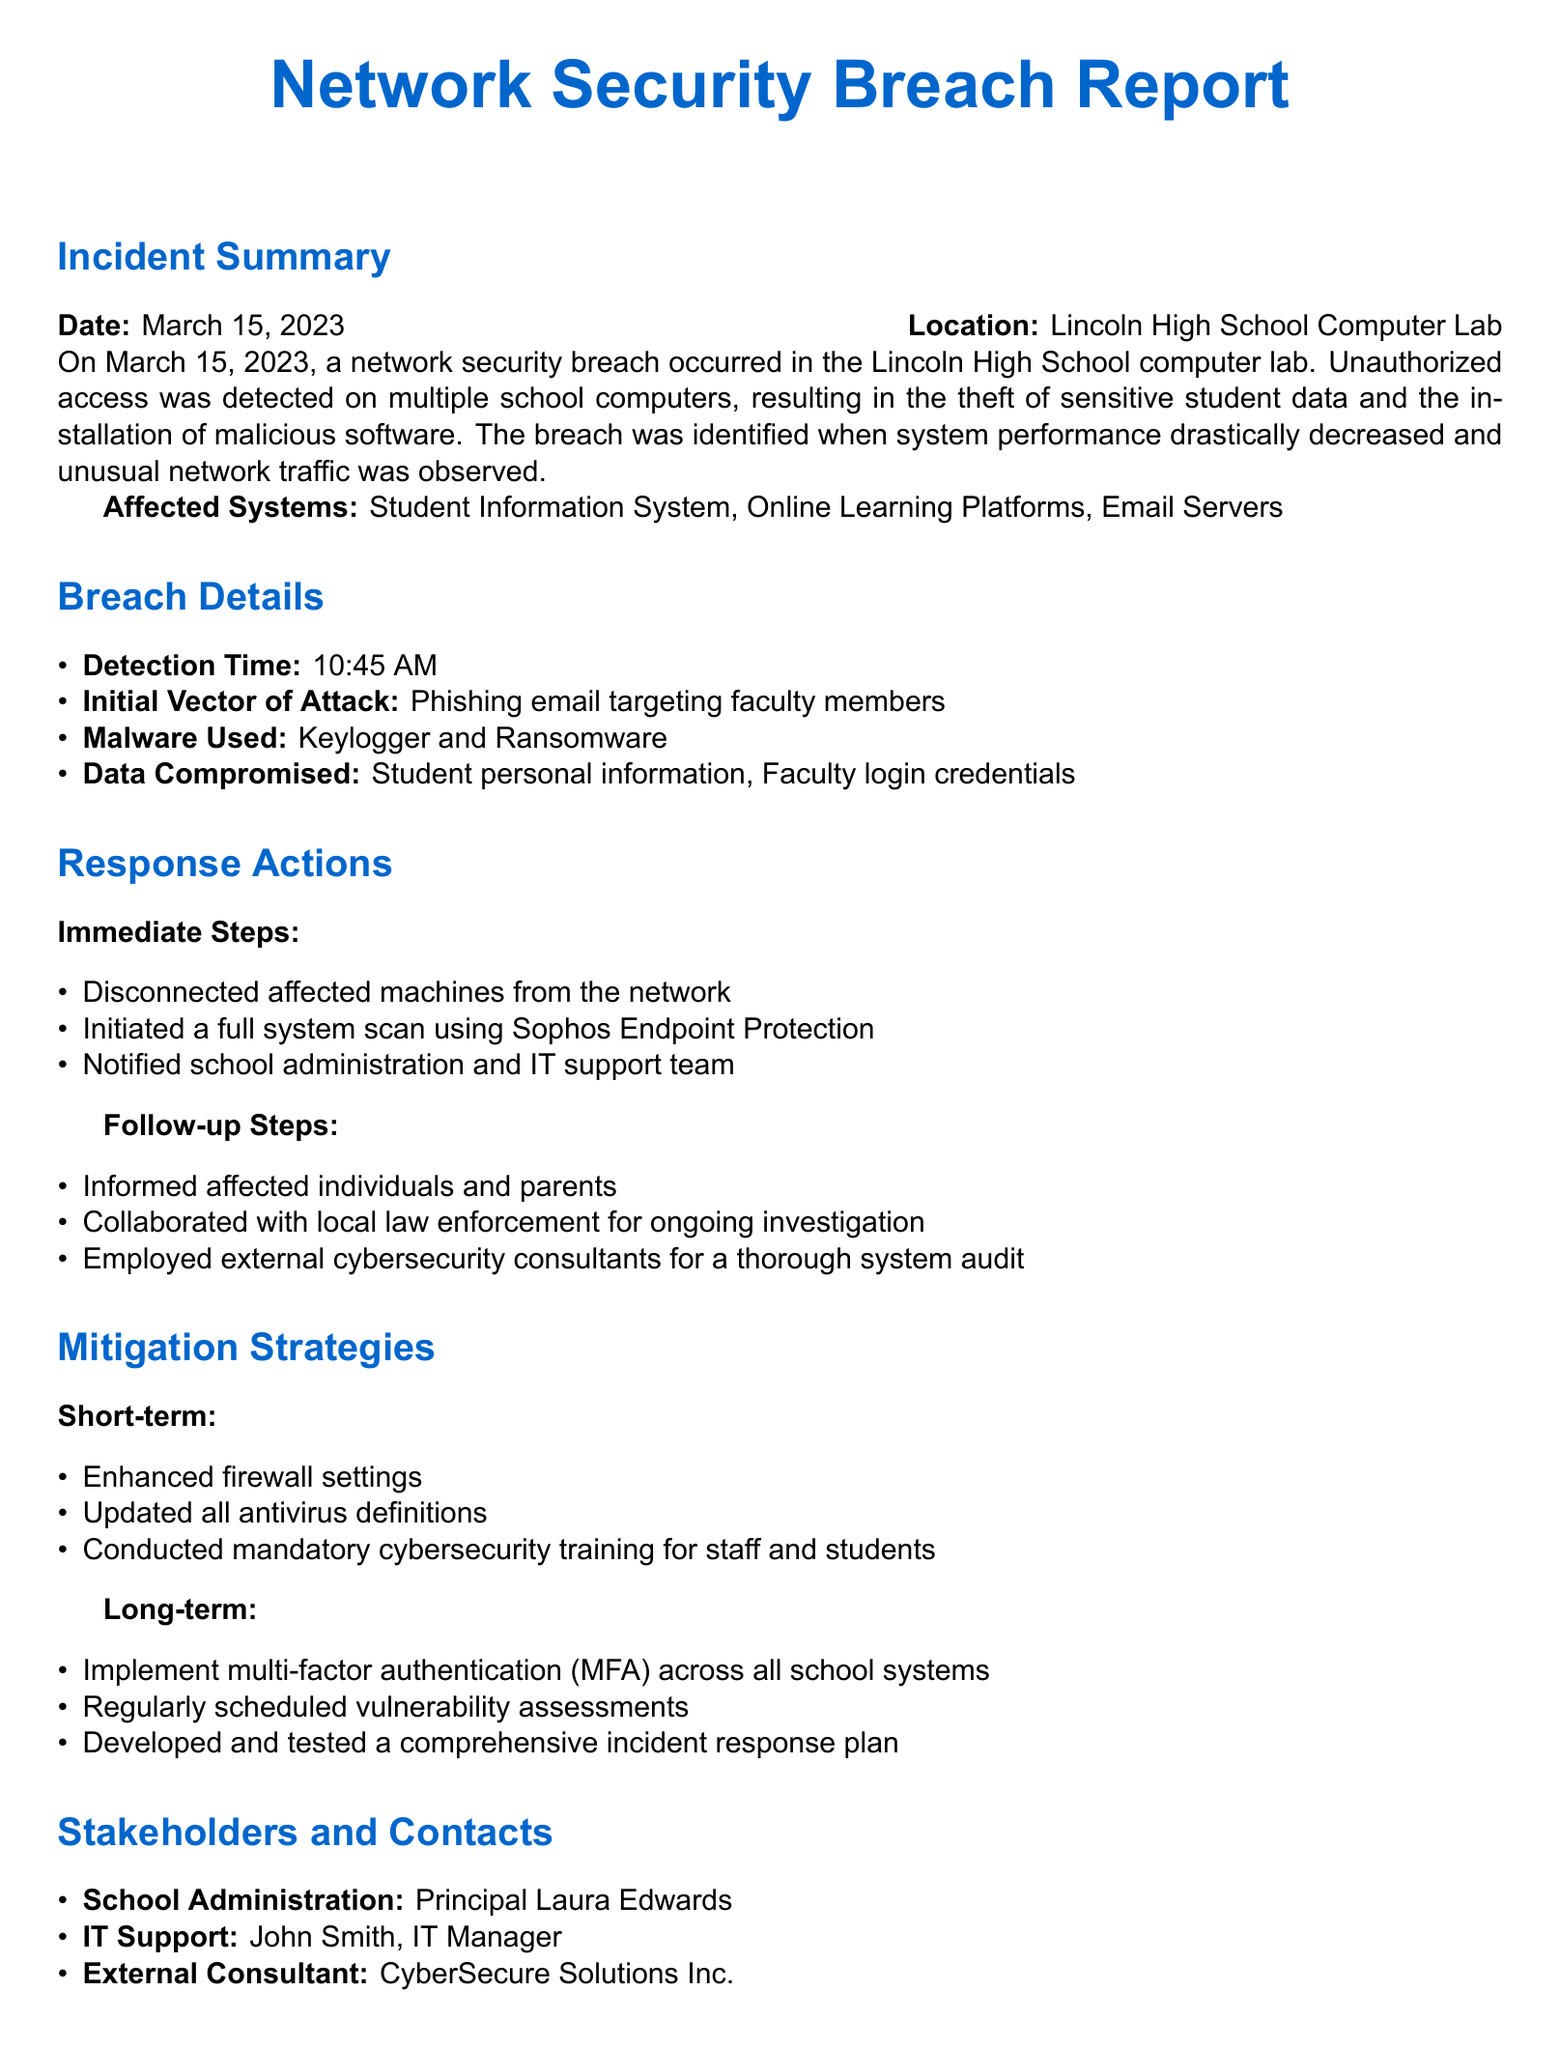What was the date of the incident? The date of the incident is explicitly stated in the document.
Answer: March 15, 2023 Where did the breach occur? The location of the breach is mentioned at the beginning of the incident summary.
Answer: Lincoln High School Computer Lab What kind of malware was used in the attack? The specific types of malware used are detailed in the breach details section.
Answer: Keylogger and Ransomware Who was notified immediately after the breach? The immediate response includes notifying specific individuals or groups as part of the response actions.
Answer: School administration and IT support team What is one of the short-term mitigation strategies? The mitigation strategies explicitly list measures taken to prevent future breaches.
Answer: Enhanced firewall settings What was the initial vector of attack? The document specifies how the breach occurred in the breach details section.
Answer: Phishing email targeting faculty members Who is the IT support manager? The incident report lists stakeholders and their roles, including names.
Answer: John Smith What does MFA stand for in the long-term strategies? The term MFA is used in the context of security measures in the mitigation strategies section.
Answer: Multi-factor authentication 